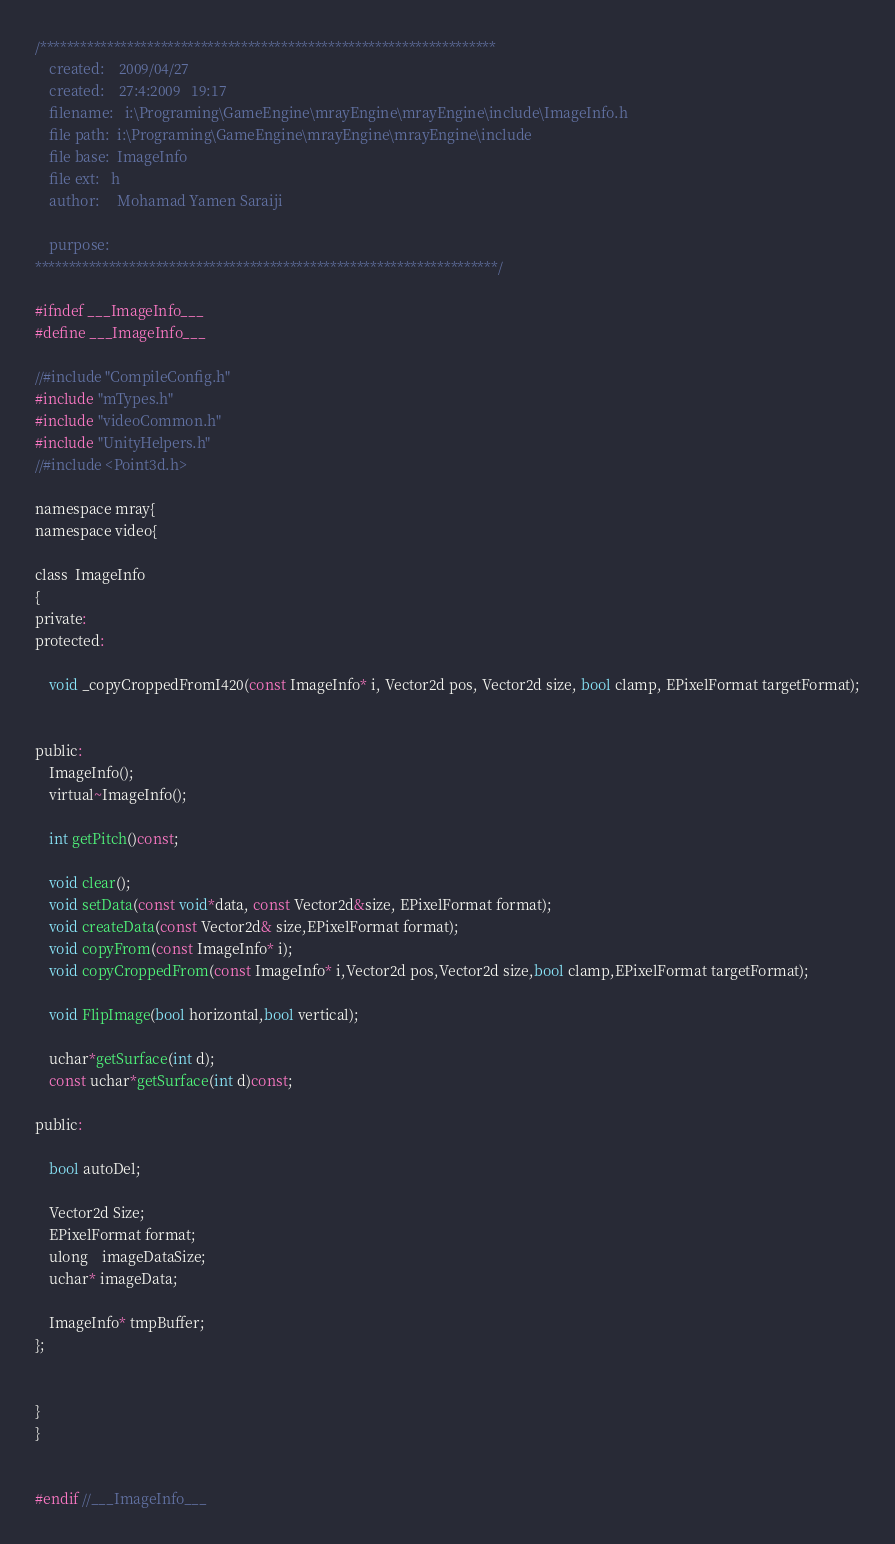<code> <loc_0><loc_0><loc_500><loc_500><_C_>
/********************************************************************
	created:	2009/04/27
	created:	27:4:2009   19:17
	filename: 	i:\Programing\GameEngine\mrayEngine\mrayEngine\include\ImageInfo.h
	file path:	i:\Programing\GameEngine\mrayEngine\mrayEngine\include
	file base:	ImageInfo
	file ext:	h
	author:		Mohamad Yamen Saraiji
	
	purpose:	
*********************************************************************/

#ifndef ___ImageInfo___
#define ___ImageInfo___

//#include "CompileConfig.h"
#include "mTypes.h"
#include "videoCommon.h"
#include "UnityHelpers.h"
//#include <Point3d.h>

namespace mray{
namespace video{

class  ImageInfo
{
private:
protected:

	void _copyCroppedFromI420(const ImageInfo* i, Vector2d pos, Vector2d size, bool clamp, EPixelFormat targetFormat);


public:
	ImageInfo();
	virtual~ImageInfo();

	int getPitch()const;

	void clear();
	void setData(const void*data, const Vector2d&size, EPixelFormat format);
	void createData(const Vector2d& size,EPixelFormat format);
    void copyFrom(const ImageInfo* i);
    void copyCroppedFrom(const ImageInfo* i,Vector2d pos,Vector2d size,bool clamp,EPixelFormat targetFormat);
    
    void FlipImage(bool horizontal,bool vertical);

	uchar*getSurface(int d);
	const uchar*getSurface(int d)const;

public:

	bool autoDel;

	Vector2d Size;
	EPixelFormat format;
	ulong	imageDataSize;
	uchar* imageData;

	ImageInfo* tmpBuffer;
};


}
}


#endif //___ImageInfo___
</code> 